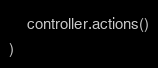<code> <loc_0><loc_0><loc_500><loc_500><_JavaScript_>    controller.actions()
)</code> 